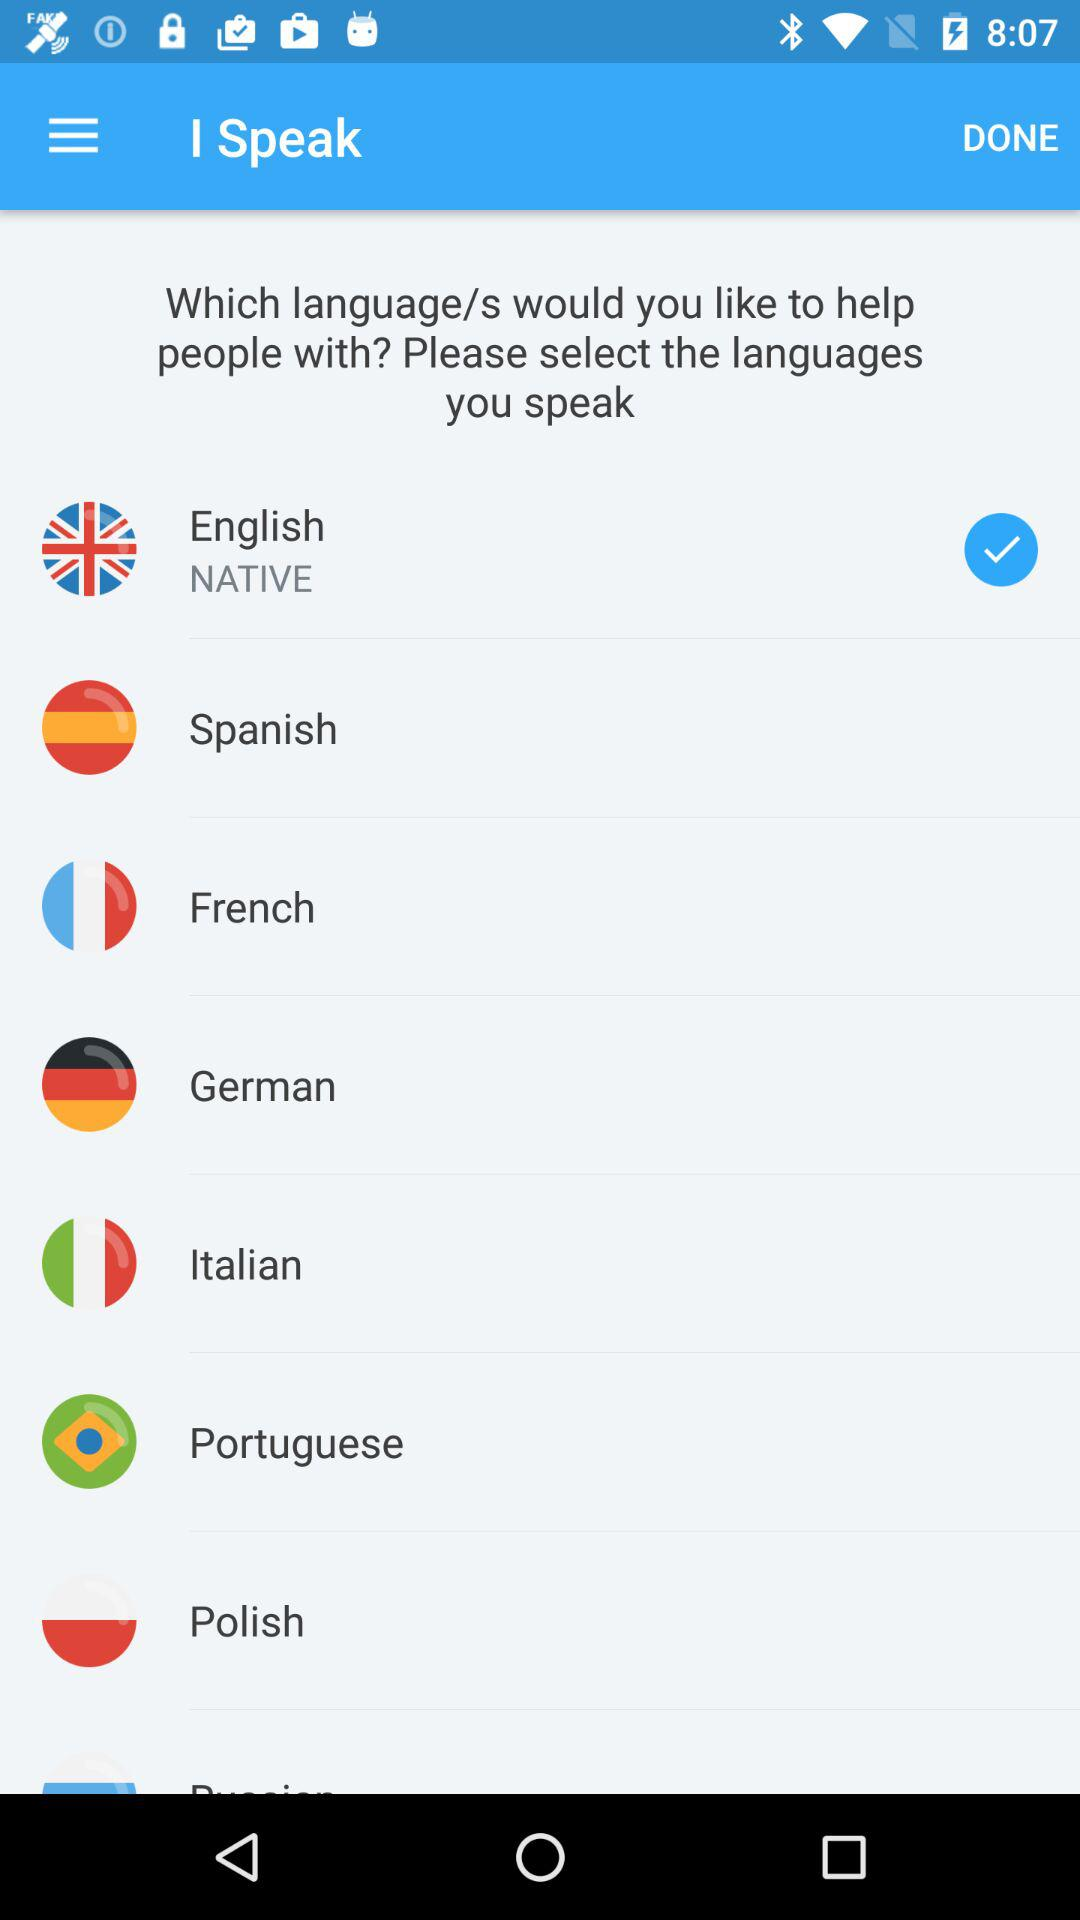How many languages are marked as native?
Answer the question using a single word or phrase. 1 